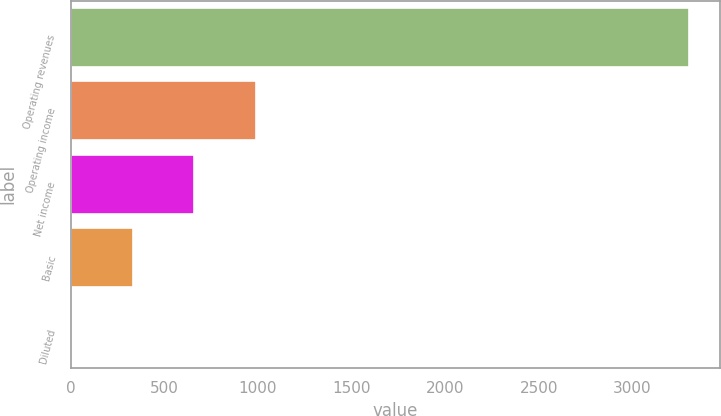Convert chart to OTSL. <chart><loc_0><loc_0><loc_500><loc_500><bar_chart><fcel>Operating revenues<fcel>Operating income<fcel>Net income<fcel>Basic<fcel>Diluted<nl><fcel>3303<fcel>991.55<fcel>661.34<fcel>331.13<fcel>0.92<nl></chart> 